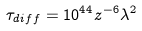<formula> <loc_0><loc_0><loc_500><loc_500>\tau _ { d i f f } = 1 0 ^ { 4 4 } z ^ { - 6 } \lambda ^ { 2 }</formula> 